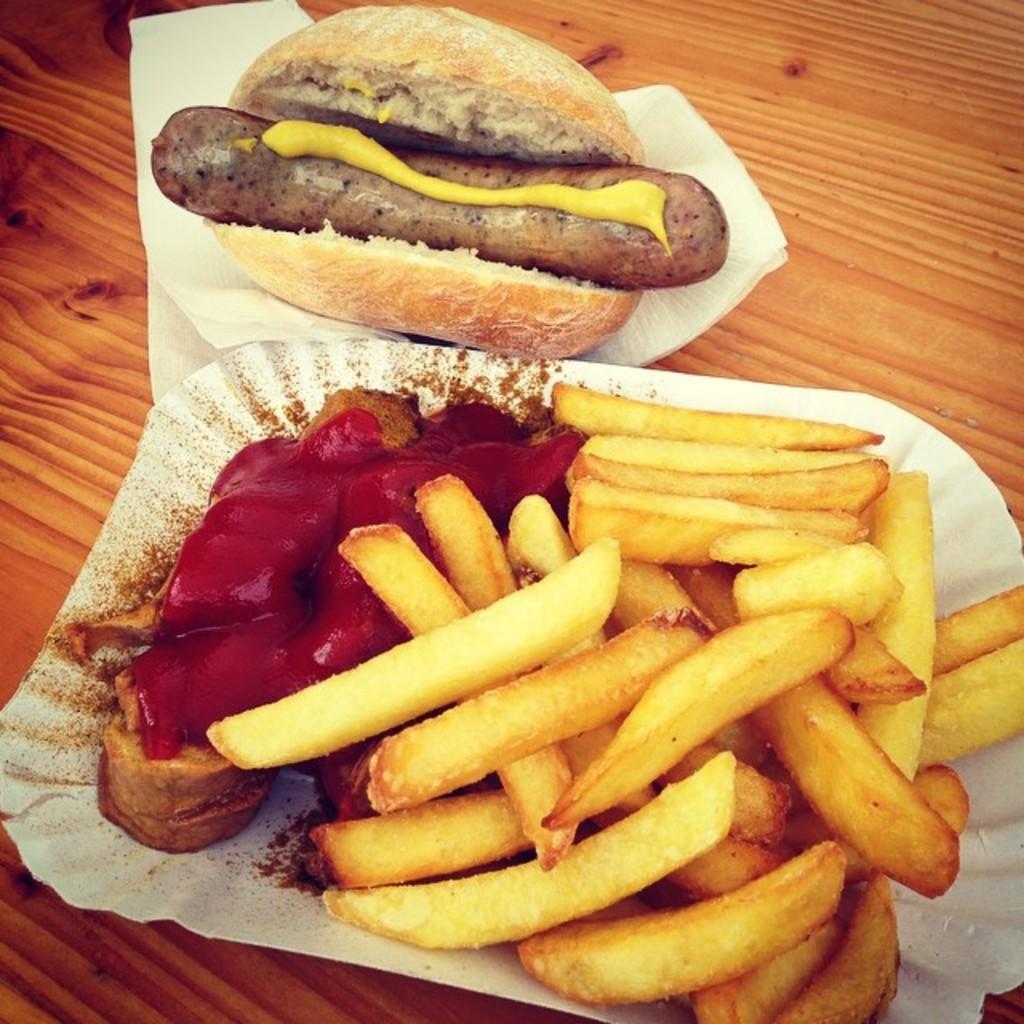In one or two sentences, can you explain what this image depicts? In this picture we can see some food items and a sausage on the papers and the papers are on the wooden item. 